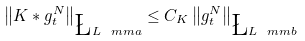Convert formula to latex. <formula><loc_0><loc_0><loc_500><loc_500>\left \| K \ast g _ { t } ^ { N } \right \| _ { \L L ^ { \ } m m { a } } \leq C _ { K } \left \| g _ { t } ^ { N } \right \| _ { \L L ^ { \ } m m { b } }</formula> 